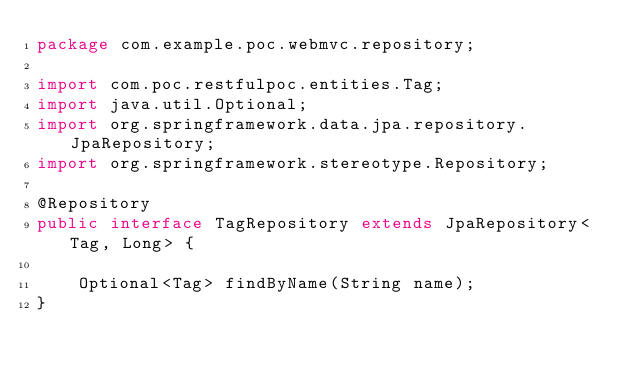Convert code to text. <code><loc_0><loc_0><loc_500><loc_500><_Java_>package com.example.poc.webmvc.repository;

import com.poc.restfulpoc.entities.Tag;
import java.util.Optional;
import org.springframework.data.jpa.repository.JpaRepository;
import org.springframework.stereotype.Repository;

@Repository
public interface TagRepository extends JpaRepository<Tag, Long> {

    Optional<Tag> findByName(String name);
}
</code> 